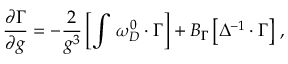<formula> <loc_0><loc_0><loc_500><loc_500>\frac { \partial \Gamma } { \partial g } = - \frac { 2 } g ^ { 3 } } \left [ \int \, \omega _ { D } ^ { 0 } \cdot \Gamma \right ] + B _ { \Gamma } \left [ \Delta ^ { - 1 } \cdot \Gamma \right ] \, ,</formula> 